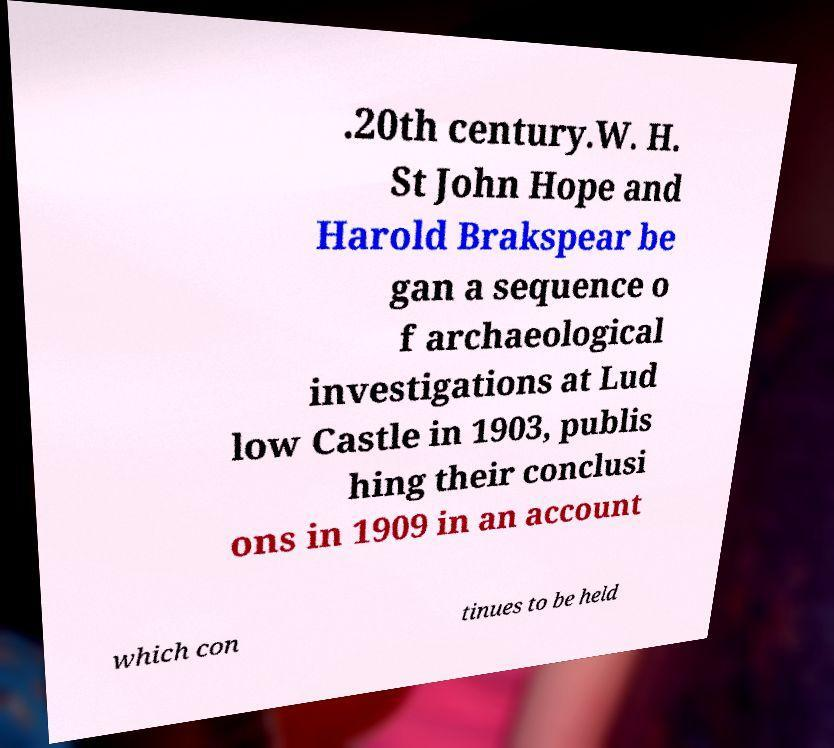Could you assist in decoding the text presented in this image and type it out clearly? .20th century.W. H. St John Hope and Harold Brakspear be gan a sequence o f archaeological investigations at Lud low Castle in 1903, publis hing their conclusi ons in 1909 in an account which con tinues to be held 